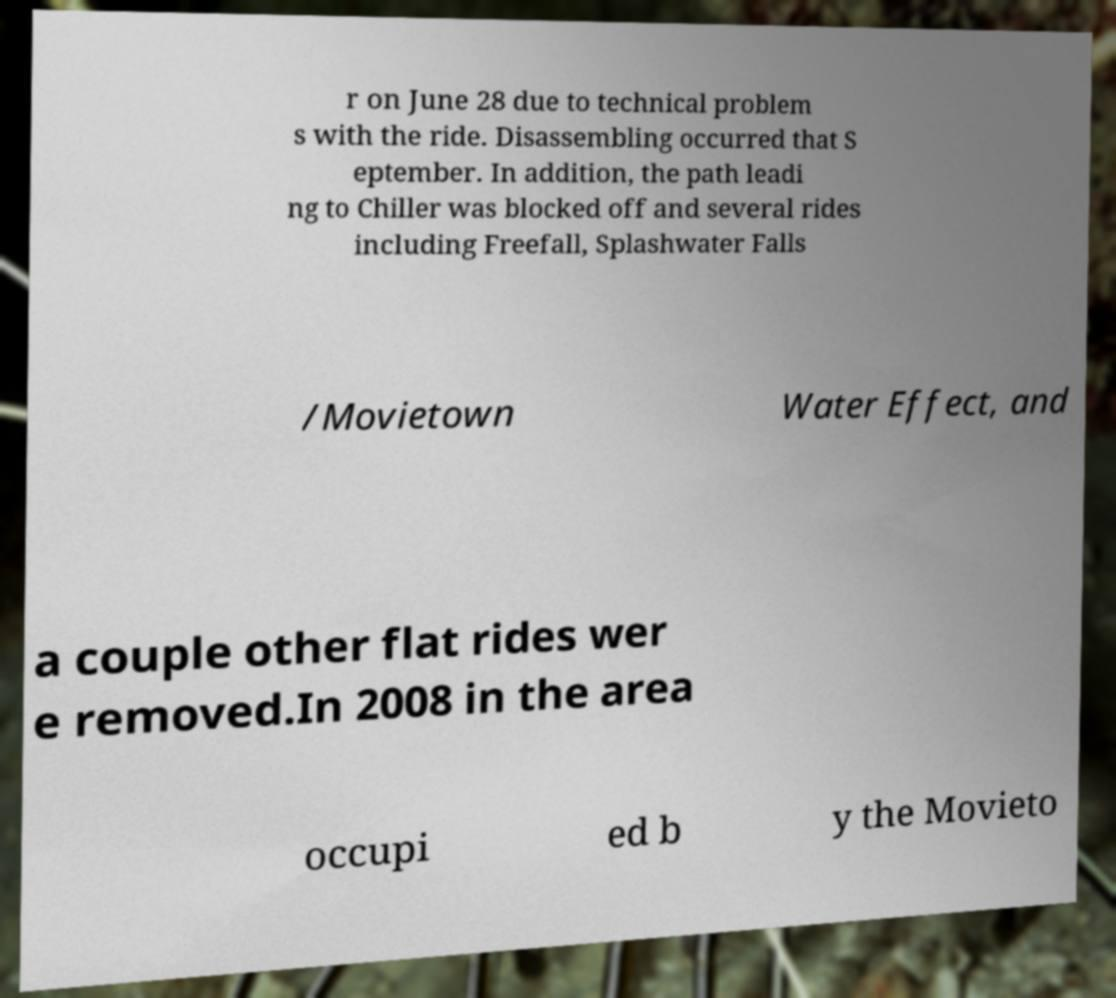Please identify and transcribe the text found in this image. r on June 28 due to technical problem s with the ride. Disassembling occurred that S eptember. In addition, the path leadi ng to Chiller was blocked off and several rides including Freefall, Splashwater Falls /Movietown Water Effect, and a couple other flat rides wer e removed.In 2008 in the area occupi ed b y the Movieto 